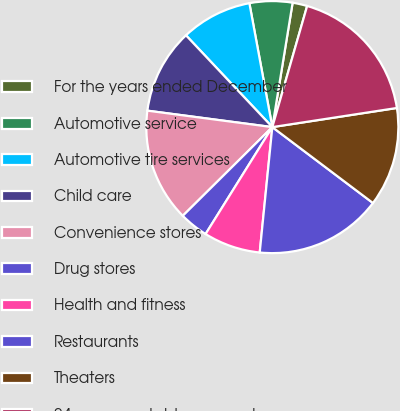Convert chart. <chart><loc_0><loc_0><loc_500><loc_500><pie_chart><fcel>For the years ended December<fcel>Automotive service<fcel>Automotive tire services<fcel>Child care<fcel>Convenience stores<fcel>Drug stores<fcel>Health and fitness<fcel>Restaurants<fcel>Theaters<fcel>24 non-reportable segments<nl><fcel>1.88%<fcel>5.49%<fcel>9.1%<fcel>10.9%<fcel>14.51%<fcel>3.69%<fcel>7.29%<fcel>16.31%<fcel>12.71%<fcel>18.12%<nl></chart> 